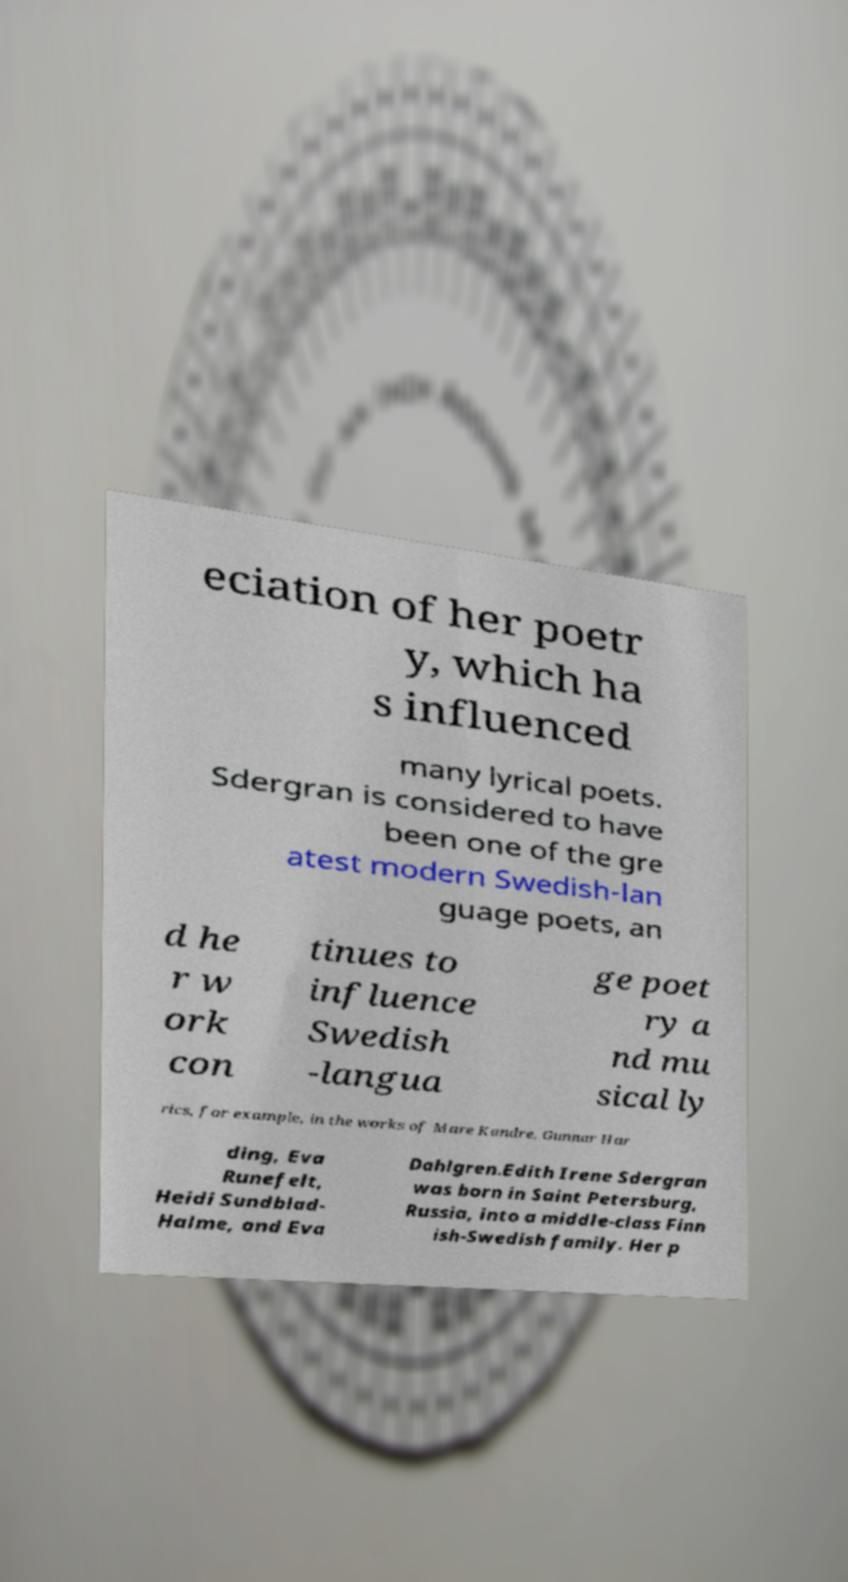Could you extract and type out the text from this image? eciation of her poetr y, which ha s influenced many lyrical poets. Sdergran is considered to have been one of the gre atest modern Swedish-lan guage poets, an d he r w ork con tinues to influence Swedish -langua ge poet ry a nd mu sical ly rics, for example, in the works of Mare Kandre, Gunnar Har ding, Eva Runefelt, Heidi Sundblad- Halme, and Eva Dahlgren.Edith Irene Sdergran was born in Saint Petersburg, Russia, into a middle-class Finn ish-Swedish family. Her p 